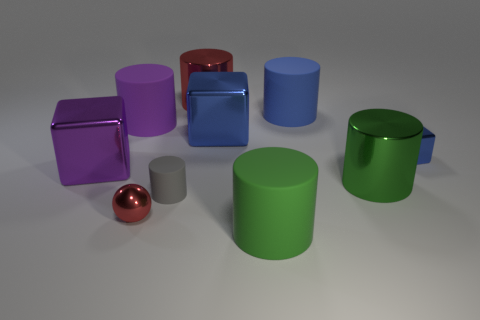How many other objects are the same color as the tiny cylinder?
Give a very brief answer. 0. What number of shiny things are left of the large matte thing in front of the big rubber cylinder that is to the left of the big red metal object?
Your response must be concise. 4. Is the size of the cube that is to the left of the purple rubber cylinder the same as the gray cylinder?
Your response must be concise. No. Are there fewer tiny red shiny balls that are behind the tiny blue shiny object than tiny blocks that are on the right side of the big blue shiny block?
Your response must be concise. Yes. Is the number of gray cylinders in front of the small gray thing less than the number of gray cylinders?
Your answer should be compact. Yes. What is the material of the cylinder that is the same color as the tiny shiny cube?
Offer a terse response. Rubber. Does the small blue block have the same material as the big purple cylinder?
Ensure brevity in your answer.  No. How many other large blue cylinders are made of the same material as the large blue cylinder?
Provide a short and direct response. 0. There is a tiny thing that is made of the same material as the tiny blue block; what is its color?
Your answer should be very brief. Red. The tiny blue object has what shape?
Offer a terse response. Cube. 